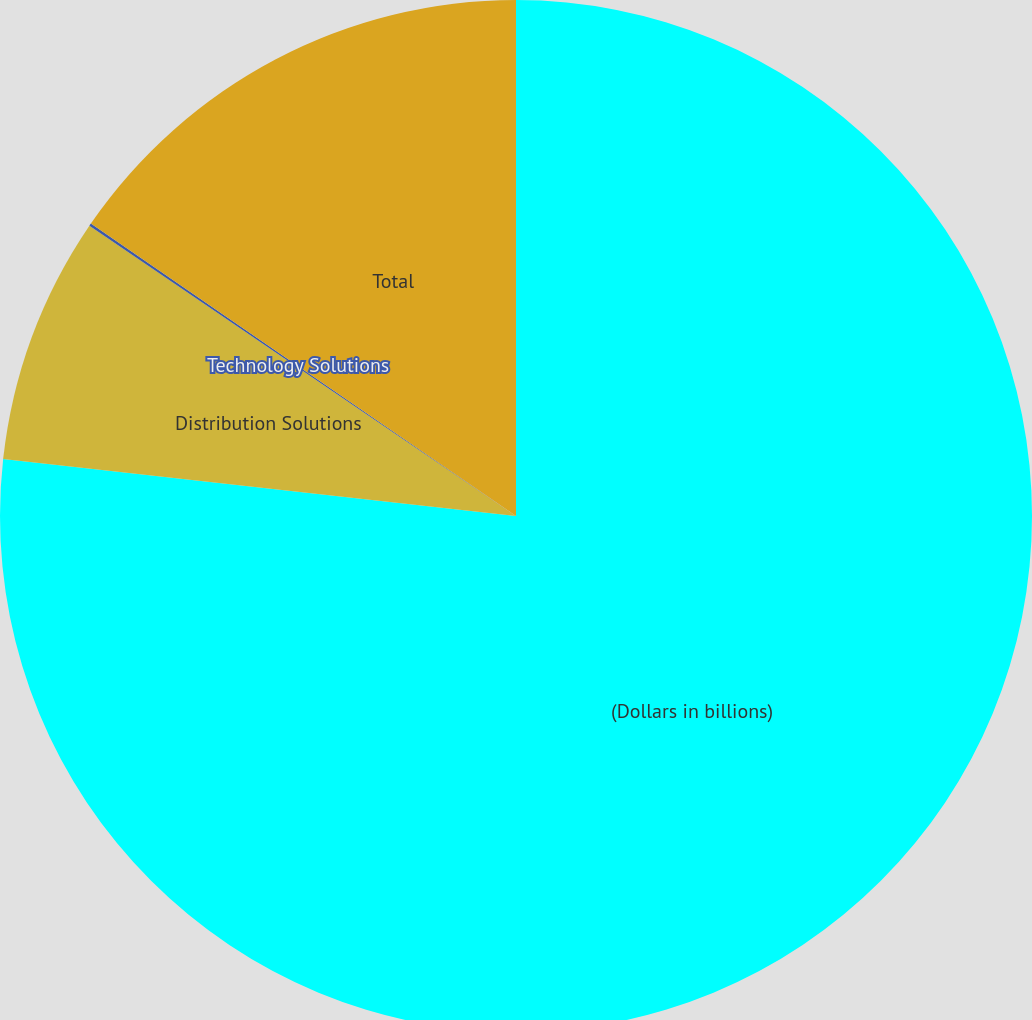<chart> <loc_0><loc_0><loc_500><loc_500><pie_chart><fcel>(Dollars in billions)<fcel>Distribution Solutions<fcel>Technology Solutions<fcel>Total<nl><fcel>76.76%<fcel>7.75%<fcel>0.08%<fcel>15.41%<nl></chart> 